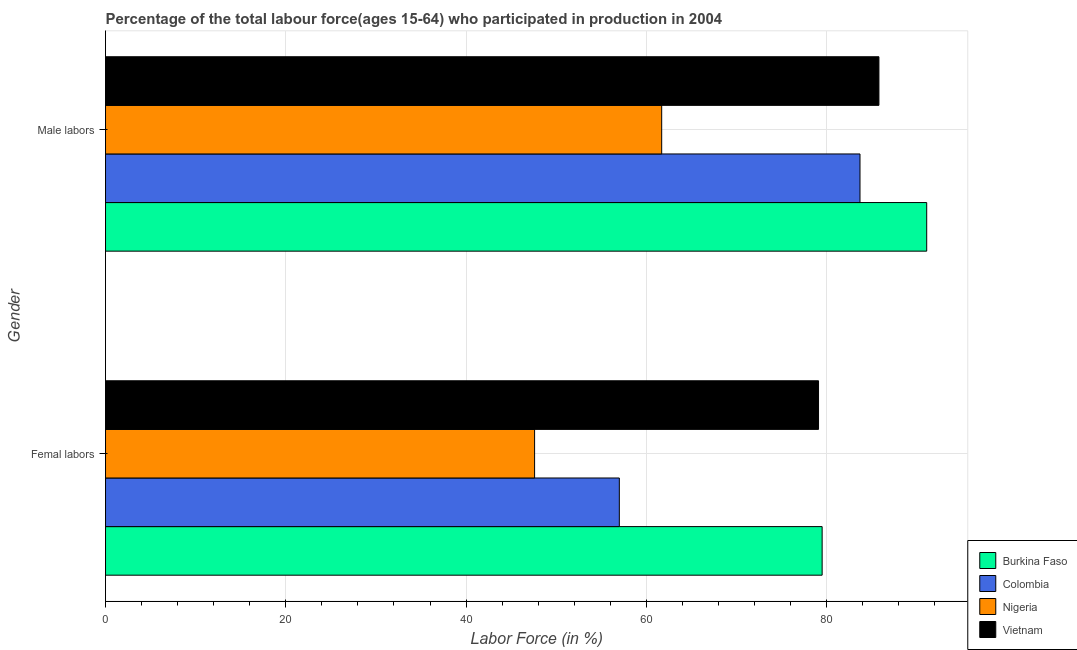How many different coloured bars are there?
Provide a succinct answer. 4. Are the number of bars on each tick of the Y-axis equal?
Keep it short and to the point. Yes. How many bars are there on the 1st tick from the bottom?
Make the answer very short. 4. What is the label of the 1st group of bars from the top?
Make the answer very short. Male labors. What is the percentage of male labour force in Colombia?
Keep it short and to the point. 83.7. Across all countries, what is the maximum percentage of male labour force?
Your answer should be very brief. 91.1. Across all countries, what is the minimum percentage of male labour force?
Your response must be concise. 61.7. In which country was the percentage of female labor force maximum?
Offer a very short reply. Burkina Faso. In which country was the percentage of female labor force minimum?
Keep it short and to the point. Nigeria. What is the total percentage of male labour force in the graph?
Your answer should be compact. 322.3. What is the difference between the percentage of female labor force in Colombia and that in Vietnam?
Offer a very short reply. -22.1. What is the difference between the percentage of female labor force in Nigeria and the percentage of male labour force in Burkina Faso?
Provide a short and direct response. -43.5. What is the average percentage of male labour force per country?
Provide a short and direct response. 80.57. What is the difference between the percentage of female labor force and percentage of male labour force in Vietnam?
Ensure brevity in your answer.  -6.7. In how many countries, is the percentage of male labour force greater than 28 %?
Provide a short and direct response. 4. What is the ratio of the percentage of female labor force in Nigeria to that in Colombia?
Make the answer very short. 0.84. In how many countries, is the percentage of female labor force greater than the average percentage of female labor force taken over all countries?
Your response must be concise. 2. What does the 2nd bar from the top in Male labors represents?
Offer a very short reply. Nigeria. What does the 1st bar from the bottom in Femal labors represents?
Provide a succinct answer. Burkina Faso. Are all the bars in the graph horizontal?
Offer a very short reply. Yes. How many countries are there in the graph?
Ensure brevity in your answer.  4. What is the difference between two consecutive major ticks on the X-axis?
Make the answer very short. 20. How are the legend labels stacked?
Your answer should be compact. Vertical. What is the title of the graph?
Ensure brevity in your answer.  Percentage of the total labour force(ages 15-64) who participated in production in 2004. What is the label or title of the Y-axis?
Your answer should be very brief. Gender. What is the Labor Force (in %) of Burkina Faso in Femal labors?
Offer a very short reply. 79.5. What is the Labor Force (in %) in Colombia in Femal labors?
Your answer should be compact. 57. What is the Labor Force (in %) in Nigeria in Femal labors?
Make the answer very short. 47.6. What is the Labor Force (in %) of Vietnam in Femal labors?
Offer a very short reply. 79.1. What is the Labor Force (in %) of Burkina Faso in Male labors?
Ensure brevity in your answer.  91.1. What is the Labor Force (in %) of Colombia in Male labors?
Ensure brevity in your answer.  83.7. What is the Labor Force (in %) in Nigeria in Male labors?
Make the answer very short. 61.7. What is the Labor Force (in %) in Vietnam in Male labors?
Your answer should be compact. 85.8. Across all Gender, what is the maximum Labor Force (in %) in Burkina Faso?
Provide a succinct answer. 91.1. Across all Gender, what is the maximum Labor Force (in %) of Colombia?
Provide a succinct answer. 83.7. Across all Gender, what is the maximum Labor Force (in %) in Nigeria?
Keep it short and to the point. 61.7. Across all Gender, what is the maximum Labor Force (in %) of Vietnam?
Offer a very short reply. 85.8. Across all Gender, what is the minimum Labor Force (in %) of Burkina Faso?
Your answer should be very brief. 79.5. Across all Gender, what is the minimum Labor Force (in %) in Colombia?
Ensure brevity in your answer.  57. Across all Gender, what is the minimum Labor Force (in %) of Nigeria?
Provide a short and direct response. 47.6. Across all Gender, what is the minimum Labor Force (in %) of Vietnam?
Make the answer very short. 79.1. What is the total Labor Force (in %) in Burkina Faso in the graph?
Give a very brief answer. 170.6. What is the total Labor Force (in %) of Colombia in the graph?
Keep it short and to the point. 140.7. What is the total Labor Force (in %) in Nigeria in the graph?
Keep it short and to the point. 109.3. What is the total Labor Force (in %) in Vietnam in the graph?
Make the answer very short. 164.9. What is the difference between the Labor Force (in %) in Burkina Faso in Femal labors and that in Male labors?
Provide a succinct answer. -11.6. What is the difference between the Labor Force (in %) of Colombia in Femal labors and that in Male labors?
Keep it short and to the point. -26.7. What is the difference between the Labor Force (in %) in Nigeria in Femal labors and that in Male labors?
Provide a succinct answer. -14.1. What is the difference between the Labor Force (in %) of Burkina Faso in Femal labors and the Labor Force (in %) of Colombia in Male labors?
Offer a terse response. -4.2. What is the difference between the Labor Force (in %) in Burkina Faso in Femal labors and the Labor Force (in %) in Nigeria in Male labors?
Ensure brevity in your answer.  17.8. What is the difference between the Labor Force (in %) in Burkina Faso in Femal labors and the Labor Force (in %) in Vietnam in Male labors?
Your answer should be very brief. -6.3. What is the difference between the Labor Force (in %) of Colombia in Femal labors and the Labor Force (in %) of Vietnam in Male labors?
Give a very brief answer. -28.8. What is the difference between the Labor Force (in %) in Nigeria in Femal labors and the Labor Force (in %) in Vietnam in Male labors?
Keep it short and to the point. -38.2. What is the average Labor Force (in %) in Burkina Faso per Gender?
Offer a terse response. 85.3. What is the average Labor Force (in %) in Colombia per Gender?
Keep it short and to the point. 70.35. What is the average Labor Force (in %) of Nigeria per Gender?
Provide a succinct answer. 54.65. What is the average Labor Force (in %) of Vietnam per Gender?
Offer a terse response. 82.45. What is the difference between the Labor Force (in %) in Burkina Faso and Labor Force (in %) in Nigeria in Femal labors?
Make the answer very short. 31.9. What is the difference between the Labor Force (in %) in Colombia and Labor Force (in %) in Nigeria in Femal labors?
Your answer should be very brief. 9.4. What is the difference between the Labor Force (in %) of Colombia and Labor Force (in %) of Vietnam in Femal labors?
Provide a short and direct response. -22.1. What is the difference between the Labor Force (in %) in Nigeria and Labor Force (in %) in Vietnam in Femal labors?
Offer a terse response. -31.5. What is the difference between the Labor Force (in %) of Burkina Faso and Labor Force (in %) of Colombia in Male labors?
Make the answer very short. 7.4. What is the difference between the Labor Force (in %) of Burkina Faso and Labor Force (in %) of Nigeria in Male labors?
Your response must be concise. 29.4. What is the difference between the Labor Force (in %) of Burkina Faso and Labor Force (in %) of Vietnam in Male labors?
Make the answer very short. 5.3. What is the difference between the Labor Force (in %) of Nigeria and Labor Force (in %) of Vietnam in Male labors?
Offer a very short reply. -24.1. What is the ratio of the Labor Force (in %) in Burkina Faso in Femal labors to that in Male labors?
Your answer should be compact. 0.87. What is the ratio of the Labor Force (in %) in Colombia in Femal labors to that in Male labors?
Offer a terse response. 0.68. What is the ratio of the Labor Force (in %) of Nigeria in Femal labors to that in Male labors?
Your answer should be compact. 0.77. What is the ratio of the Labor Force (in %) of Vietnam in Femal labors to that in Male labors?
Your answer should be very brief. 0.92. What is the difference between the highest and the second highest Labor Force (in %) of Burkina Faso?
Ensure brevity in your answer.  11.6. What is the difference between the highest and the second highest Labor Force (in %) of Colombia?
Your answer should be compact. 26.7. What is the difference between the highest and the second highest Labor Force (in %) in Nigeria?
Ensure brevity in your answer.  14.1. What is the difference between the highest and the lowest Labor Force (in %) of Burkina Faso?
Make the answer very short. 11.6. What is the difference between the highest and the lowest Labor Force (in %) in Colombia?
Provide a short and direct response. 26.7. 